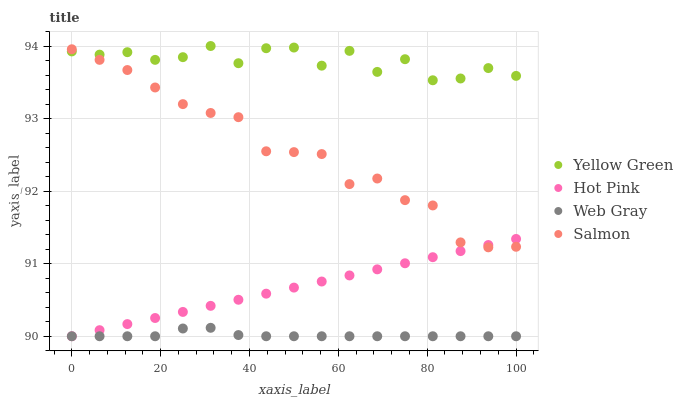Does Web Gray have the minimum area under the curve?
Answer yes or no. Yes. Does Yellow Green have the maximum area under the curve?
Answer yes or no. Yes. Does Hot Pink have the minimum area under the curve?
Answer yes or no. No. Does Hot Pink have the maximum area under the curve?
Answer yes or no. No. Is Hot Pink the smoothest?
Answer yes or no. Yes. Is Yellow Green the roughest?
Answer yes or no. Yes. Is Web Gray the smoothest?
Answer yes or no. No. Is Web Gray the roughest?
Answer yes or no. No. Does Hot Pink have the lowest value?
Answer yes or no. Yes. Does Yellow Green have the lowest value?
Answer yes or no. No. Does Yellow Green have the highest value?
Answer yes or no. Yes. Does Hot Pink have the highest value?
Answer yes or no. No. Is Web Gray less than Salmon?
Answer yes or no. Yes. Is Yellow Green greater than Web Gray?
Answer yes or no. Yes. Does Hot Pink intersect Web Gray?
Answer yes or no. Yes. Is Hot Pink less than Web Gray?
Answer yes or no. No. Is Hot Pink greater than Web Gray?
Answer yes or no. No. Does Web Gray intersect Salmon?
Answer yes or no. No. 